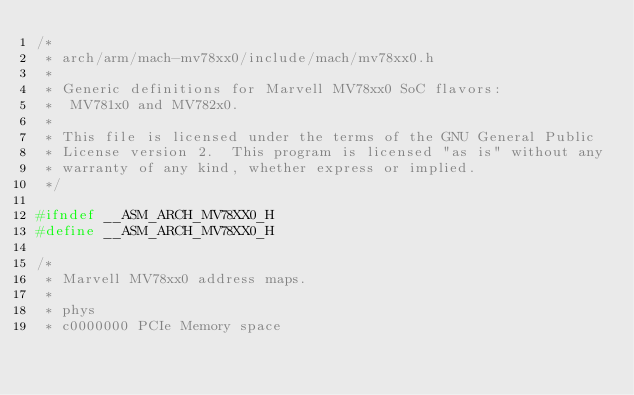Convert code to text. <code><loc_0><loc_0><loc_500><loc_500><_C_>/*
 * arch/arm/mach-mv78xx0/include/mach/mv78xx0.h
 *
 * Generic definitions for Marvell MV78xx0 SoC flavors:
 *  MV781x0 and MV782x0.
 *
 * This file is licensed under the terms of the GNU General Public
 * License version 2.  This program is licensed "as is" without any
 * warranty of any kind, whether express or implied.
 */

#ifndef __ASM_ARCH_MV78XX0_H
#define __ASM_ARCH_MV78XX0_H

/*
 * Marvell MV78xx0 address maps.
 *
 * phys
 * c0000000	PCIe Memory space</code> 